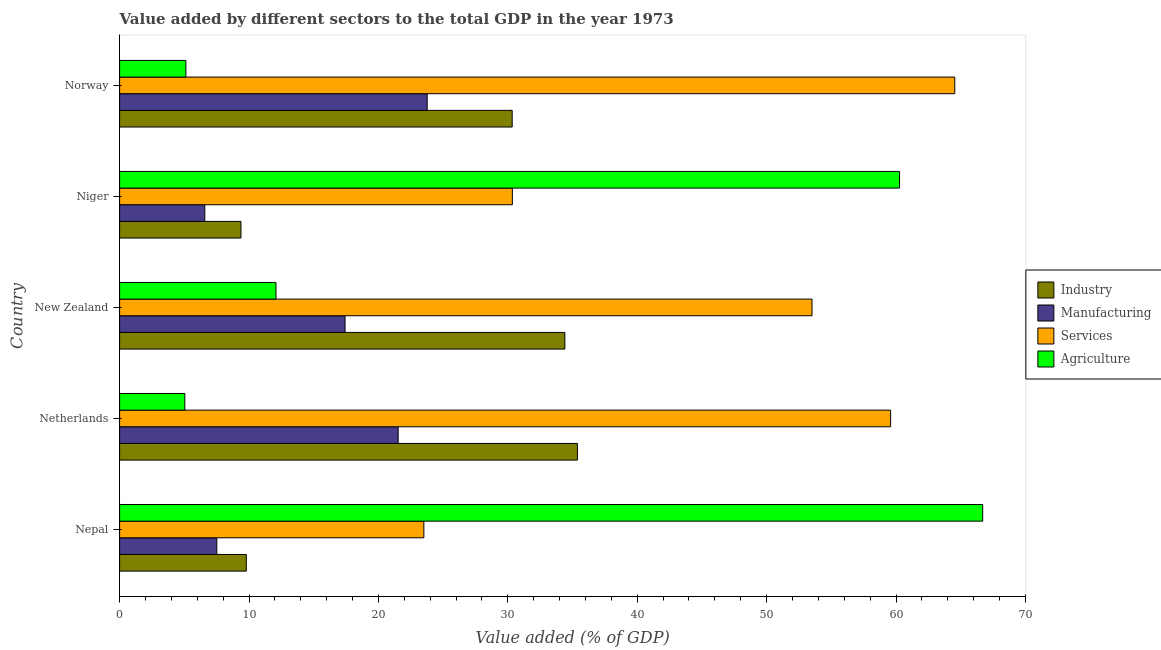How many groups of bars are there?
Give a very brief answer. 5. Are the number of bars per tick equal to the number of legend labels?
Provide a succinct answer. Yes. How many bars are there on the 3rd tick from the top?
Keep it short and to the point. 4. What is the label of the 1st group of bars from the top?
Keep it short and to the point. Norway. What is the value added by agricultural sector in Netherlands?
Provide a succinct answer. 5.04. Across all countries, what is the maximum value added by agricultural sector?
Give a very brief answer. 66.7. Across all countries, what is the minimum value added by manufacturing sector?
Offer a very short reply. 6.58. In which country was the value added by agricultural sector maximum?
Keep it short and to the point. Nepal. In which country was the value added by agricultural sector minimum?
Your answer should be very brief. Netherlands. What is the total value added by industrial sector in the graph?
Ensure brevity in your answer.  119.29. What is the difference between the value added by industrial sector in Niger and that in Norway?
Your answer should be compact. -20.96. What is the difference between the value added by services sector in Netherlands and the value added by agricultural sector in Nepal?
Offer a terse response. -7.12. What is the average value added by services sector per country?
Provide a succinct answer. 46.3. What is the difference between the value added by industrial sector and value added by agricultural sector in Netherlands?
Ensure brevity in your answer.  30.34. What is the ratio of the value added by agricultural sector in Nepal to that in Niger?
Make the answer very short. 1.11. Is the difference between the value added by agricultural sector in New Zealand and Niger greater than the difference between the value added by industrial sector in New Zealand and Niger?
Give a very brief answer. No. What is the difference between the highest and the second highest value added by services sector?
Provide a short and direct response. 4.96. What is the difference between the highest and the lowest value added by manufacturing sector?
Your answer should be very brief. 17.19. In how many countries, is the value added by agricultural sector greater than the average value added by agricultural sector taken over all countries?
Your response must be concise. 2. Is the sum of the value added by agricultural sector in New Zealand and Norway greater than the maximum value added by manufacturing sector across all countries?
Give a very brief answer. No. What does the 3rd bar from the top in New Zealand represents?
Your response must be concise. Manufacturing. What does the 2nd bar from the bottom in Netherlands represents?
Keep it short and to the point. Manufacturing. Are all the bars in the graph horizontal?
Your answer should be very brief. Yes. What is the difference between two consecutive major ticks on the X-axis?
Offer a very short reply. 10. Does the graph contain grids?
Ensure brevity in your answer.  No. How many legend labels are there?
Provide a succinct answer. 4. How are the legend labels stacked?
Your answer should be very brief. Vertical. What is the title of the graph?
Offer a terse response. Value added by different sectors to the total GDP in the year 1973. What is the label or title of the X-axis?
Keep it short and to the point. Value added (% of GDP). What is the Value added (% of GDP) of Industry in Nepal?
Keep it short and to the point. 9.79. What is the Value added (% of GDP) in Manufacturing in Nepal?
Provide a succinct answer. 7.51. What is the Value added (% of GDP) in Services in Nepal?
Provide a succinct answer. 23.51. What is the Value added (% of GDP) of Agriculture in Nepal?
Give a very brief answer. 66.7. What is the Value added (% of GDP) in Industry in Netherlands?
Offer a terse response. 35.38. What is the Value added (% of GDP) in Manufacturing in Netherlands?
Offer a terse response. 21.53. What is the Value added (% of GDP) in Services in Netherlands?
Make the answer very short. 59.58. What is the Value added (% of GDP) in Agriculture in Netherlands?
Offer a very short reply. 5.04. What is the Value added (% of GDP) of Industry in New Zealand?
Ensure brevity in your answer.  34.41. What is the Value added (% of GDP) of Manufacturing in New Zealand?
Offer a terse response. 17.42. What is the Value added (% of GDP) in Services in New Zealand?
Make the answer very short. 53.51. What is the Value added (% of GDP) in Agriculture in New Zealand?
Make the answer very short. 12.08. What is the Value added (% of GDP) of Industry in Niger?
Make the answer very short. 9.38. What is the Value added (% of GDP) in Manufacturing in Niger?
Your answer should be very brief. 6.58. What is the Value added (% of GDP) in Services in Niger?
Give a very brief answer. 30.35. What is the Value added (% of GDP) of Agriculture in Niger?
Your response must be concise. 60.27. What is the Value added (% of GDP) in Industry in Norway?
Offer a terse response. 30.34. What is the Value added (% of GDP) of Manufacturing in Norway?
Provide a succinct answer. 23.77. What is the Value added (% of GDP) of Services in Norway?
Your answer should be very brief. 64.54. What is the Value added (% of GDP) of Agriculture in Norway?
Offer a very short reply. 5.12. Across all countries, what is the maximum Value added (% of GDP) of Industry?
Offer a very short reply. 35.38. Across all countries, what is the maximum Value added (% of GDP) in Manufacturing?
Offer a very short reply. 23.77. Across all countries, what is the maximum Value added (% of GDP) in Services?
Provide a short and direct response. 64.54. Across all countries, what is the maximum Value added (% of GDP) in Agriculture?
Make the answer very short. 66.7. Across all countries, what is the minimum Value added (% of GDP) of Industry?
Provide a succinct answer. 9.38. Across all countries, what is the minimum Value added (% of GDP) of Manufacturing?
Provide a succinct answer. 6.58. Across all countries, what is the minimum Value added (% of GDP) in Services?
Provide a succinct answer. 23.51. Across all countries, what is the minimum Value added (% of GDP) in Agriculture?
Your response must be concise. 5.04. What is the total Value added (% of GDP) in Industry in the graph?
Offer a terse response. 119.29. What is the total Value added (% of GDP) of Manufacturing in the graph?
Offer a terse response. 76.81. What is the total Value added (% of GDP) of Services in the graph?
Your answer should be compact. 231.49. What is the total Value added (% of GDP) in Agriculture in the graph?
Offer a terse response. 149.22. What is the difference between the Value added (% of GDP) of Industry in Nepal and that in Netherlands?
Your answer should be very brief. -25.59. What is the difference between the Value added (% of GDP) in Manufacturing in Nepal and that in Netherlands?
Provide a succinct answer. -14.02. What is the difference between the Value added (% of GDP) of Services in Nepal and that in Netherlands?
Offer a very short reply. -36.07. What is the difference between the Value added (% of GDP) in Agriculture in Nepal and that in Netherlands?
Your response must be concise. 61.66. What is the difference between the Value added (% of GDP) in Industry in Nepal and that in New Zealand?
Give a very brief answer. -24.62. What is the difference between the Value added (% of GDP) of Manufacturing in Nepal and that in New Zealand?
Your response must be concise. -9.91. What is the difference between the Value added (% of GDP) of Services in Nepal and that in New Zealand?
Give a very brief answer. -29.99. What is the difference between the Value added (% of GDP) of Agriculture in Nepal and that in New Zealand?
Your answer should be compact. 54.61. What is the difference between the Value added (% of GDP) of Industry in Nepal and that in Niger?
Offer a very short reply. 0.41. What is the difference between the Value added (% of GDP) in Manufacturing in Nepal and that in Niger?
Your answer should be very brief. 0.93. What is the difference between the Value added (% of GDP) of Services in Nepal and that in Niger?
Offer a terse response. -6.84. What is the difference between the Value added (% of GDP) of Agriculture in Nepal and that in Niger?
Your answer should be compact. 6.43. What is the difference between the Value added (% of GDP) of Industry in Nepal and that in Norway?
Ensure brevity in your answer.  -20.55. What is the difference between the Value added (% of GDP) in Manufacturing in Nepal and that in Norway?
Keep it short and to the point. -16.26. What is the difference between the Value added (% of GDP) of Services in Nepal and that in Norway?
Offer a very short reply. -41.03. What is the difference between the Value added (% of GDP) of Agriculture in Nepal and that in Norway?
Offer a terse response. 61.57. What is the difference between the Value added (% of GDP) in Industry in Netherlands and that in New Zealand?
Give a very brief answer. 0.97. What is the difference between the Value added (% of GDP) of Manufacturing in Netherlands and that in New Zealand?
Offer a very short reply. 4.1. What is the difference between the Value added (% of GDP) in Services in Netherlands and that in New Zealand?
Offer a very short reply. 6.07. What is the difference between the Value added (% of GDP) of Agriculture in Netherlands and that in New Zealand?
Your answer should be very brief. -7.04. What is the difference between the Value added (% of GDP) of Industry in Netherlands and that in Niger?
Provide a succinct answer. 26. What is the difference between the Value added (% of GDP) in Manufacturing in Netherlands and that in Niger?
Your response must be concise. 14.94. What is the difference between the Value added (% of GDP) in Services in Netherlands and that in Niger?
Provide a succinct answer. 29.23. What is the difference between the Value added (% of GDP) in Agriculture in Netherlands and that in Niger?
Keep it short and to the point. -55.23. What is the difference between the Value added (% of GDP) of Industry in Netherlands and that in Norway?
Your response must be concise. 5.04. What is the difference between the Value added (% of GDP) of Manufacturing in Netherlands and that in Norway?
Offer a very short reply. -2.24. What is the difference between the Value added (% of GDP) in Services in Netherlands and that in Norway?
Your answer should be very brief. -4.96. What is the difference between the Value added (% of GDP) in Agriculture in Netherlands and that in Norway?
Your answer should be compact. -0.08. What is the difference between the Value added (% of GDP) in Industry in New Zealand and that in Niger?
Your response must be concise. 25.03. What is the difference between the Value added (% of GDP) in Manufacturing in New Zealand and that in Niger?
Ensure brevity in your answer.  10.84. What is the difference between the Value added (% of GDP) of Services in New Zealand and that in Niger?
Make the answer very short. 23.16. What is the difference between the Value added (% of GDP) of Agriculture in New Zealand and that in Niger?
Provide a succinct answer. -48.19. What is the difference between the Value added (% of GDP) of Industry in New Zealand and that in Norway?
Offer a terse response. 4.07. What is the difference between the Value added (% of GDP) in Manufacturing in New Zealand and that in Norway?
Offer a very short reply. -6.35. What is the difference between the Value added (% of GDP) of Services in New Zealand and that in Norway?
Your answer should be compact. -11.03. What is the difference between the Value added (% of GDP) in Agriculture in New Zealand and that in Norway?
Your answer should be very brief. 6.96. What is the difference between the Value added (% of GDP) in Industry in Niger and that in Norway?
Your response must be concise. -20.96. What is the difference between the Value added (% of GDP) of Manufacturing in Niger and that in Norway?
Offer a very short reply. -17.19. What is the difference between the Value added (% of GDP) in Services in Niger and that in Norway?
Make the answer very short. -34.19. What is the difference between the Value added (% of GDP) of Agriculture in Niger and that in Norway?
Make the answer very short. 55.15. What is the difference between the Value added (% of GDP) in Industry in Nepal and the Value added (% of GDP) in Manufacturing in Netherlands?
Provide a short and direct response. -11.74. What is the difference between the Value added (% of GDP) in Industry in Nepal and the Value added (% of GDP) in Services in Netherlands?
Offer a terse response. -49.79. What is the difference between the Value added (% of GDP) in Industry in Nepal and the Value added (% of GDP) in Agriculture in Netherlands?
Give a very brief answer. 4.75. What is the difference between the Value added (% of GDP) of Manufacturing in Nepal and the Value added (% of GDP) of Services in Netherlands?
Give a very brief answer. -52.07. What is the difference between the Value added (% of GDP) in Manufacturing in Nepal and the Value added (% of GDP) in Agriculture in Netherlands?
Your response must be concise. 2.47. What is the difference between the Value added (% of GDP) in Services in Nepal and the Value added (% of GDP) in Agriculture in Netherlands?
Keep it short and to the point. 18.47. What is the difference between the Value added (% of GDP) of Industry in Nepal and the Value added (% of GDP) of Manufacturing in New Zealand?
Provide a short and direct response. -7.63. What is the difference between the Value added (% of GDP) in Industry in Nepal and the Value added (% of GDP) in Services in New Zealand?
Provide a succinct answer. -43.72. What is the difference between the Value added (% of GDP) in Industry in Nepal and the Value added (% of GDP) in Agriculture in New Zealand?
Your answer should be compact. -2.29. What is the difference between the Value added (% of GDP) of Manufacturing in Nepal and the Value added (% of GDP) of Services in New Zealand?
Make the answer very short. -46. What is the difference between the Value added (% of GDP) in Manufacturing in Nepal and the Value added (% of GDP) in Agriculture in New Zealand?
Offer a very short reply. -4.57. What is the difference between the Value added (% of GDP) of Services in Nepal and the Value added (% of GDP) of Agriculture in New Zealand?
Provide a short and direct response. 11.43. What is the difference between the Value added (% of GDP) in Industry in Nepal and the Value added (% of GDP) in Manufacturing in Niger?
Ensure brevity in your answer.  3.21. What is the difference between the Value added (% of GDP) of Industry in Nepal and the Value added (% of GDP) of Services in Niger?
Give a very brief answer. -20.56. What is the difference between the Value added (% of GDP) in Industry in Nepal and the Value added (% of GDP) in Agriculture in Niger?
Your response must be concise. -50.48. What is the difference between the Value added (% of GDP) in Manufacturing in Nepal and the Value added (% of GDP) in Services in Niger?
Give a very brief answer. -22.84. What is the difference between the Value added (% of GDP) of Manufacturing in Nepal and the Value added (% of GDP) of Agriculture in Niger?
Your response must be concise. -52.76. What is the difference between the Value added (% of GDP) in Services in Nepal and the Value added (% of GDP) in Agriculture in Niger?
Ensure brevity in your answer.  -36.76. What is the difference between the Value added (% of GDP) of Industry in Nepal and the Value added (% of GDP) of Manufacturing in Norway?
Offer a very short reply. -13.98. What is the difference between the Value added (% of GDP) of Industry in Nepal and the Value added (% of GDP) of Services in Norway?
Keep it short and to the point. -54.75. What is the difference between the Value added (% of GDP) in Industry in Nepal and the Value added (% of GDP) in Agriculture in Norway?
Provide a succinct answer. 4.67. What is the difference between the Value added (% of GDP) of Manufacturing in Nepal and the Value added (% of GDP) of Services in Norway?
Offer a very short reply. -57.03. What is the difference between the Value added (% of GDP) in Manufacturing in Nepal and the Value added (% of GDP) in Agriculture in Norway?
Your answer should be very brief. 2.39. What is the difference between the Value added (% of GDP) in Services in Nepal and the Value added (% of GDP) in Agriculture in Norway?
Provide a short and direct response. 18.39. What is the difference between the Value added (% of GDP) of Industry in Netherlands and the Value added (% of GDP) of Manufacturing in New Zealand?
Make the answer very short. 17.96. What is the difference between the Value added (% of GDP) of Industry in Netherlands and the Value added (% of GDP) of Services in New Zealand?
Your response must be concise. -18.13. What is the difference between the Value added (% of GDP) of Industry in Netherlands and the Value added (% of GDP) of Agriculture in New Zealand?
Your answer should be compact. 23.3. What is the difference between the Value added (% of GDP) of Manufacturing in Netherlands and the Value added (% of GDP) of Services in New Zealand?
Ensure brevity in your answer.  -31.98. What is the difference between the Value added (% of GDP) of Manufacturing in Netherlands and the Value added (% of GDP) of Agriculture in New Zealand?
Provide a succinct answer. 9.44. What is the difference between the Value added (% of GDP) of Services in Netherlands and the Value added (% of GDP) of Agriculture in New Zealand?
Your response must be concise. 47.5. What is the difference between the Value added (% of GDP) of Industry in Netherlands and the Value added (% of GDP) of Manufacturing in Niger?
Provide a short and direct response. 28.8. What is the difference between the Value added (% of GDP) of Industry in Netherlands and the Value added (% of GDP) of Services in Niger?
Provide a short and direct response. 5.03. What is the difference between the Value added (% of GDP) in Industry in Netherlands and the Value added (% of GDP) in Agriculture in Niger?
Make the answer very short. -24.89. What is the difference between the Value added (% of GDP) of Manufacturing in Netherlands and the Value added (% of GDP) of Services in Niger?
Ensure brevity in your answer.  -8.82. What is the difference between the Value added (% of GDP) in Manufacturing in Netherlands and the Value added (% of GDP) in Agriculture in Niger?
Offer a terse response. -38.74. What is the difference between the Value added (% of GDP) of Services in Netherlands and the Value added (% of GDP) of Agriculture in Niger?
Keep it short and to the point. -0.69. What is the difference between the Value added (% of GDP) of Industry in Netherlands and the Value added (% of GDP) of Manufacturing in Norway?
Offer a terse response. 11.61. What is the difference between the Value added (% of GDP) in Industry in Netherlands and the Value added (% of GDP) in Services in Norway?
Your answer should be very brief. -29.16. What is the difference between the Value added (% of GDP) in Industry in Netherlands and the Value added (% of GDP) in Agriculture in Norway?
Make the answer very short. 30.26. What is the difference between the Value added (% of GDP) of Manufacturing in Netherlands and the Value added (% of GDP) of Services in Norway?
Provide a short and direct response. -43.01. What is the difference between the Value added (% of GDP) of Manufacturing in Netherlands and the Value added (% of GDP) of Agriculture in Norway?
Make the answer very short. 16.4. What is the difference between the Value added (% of GDP) in Services in Netherlands and the Value added (% of GDP) in Agriculture in Norway?
Your answer should be very brief. 54.46. What is the difference between the Value added (% of GDP) in Industry in New Zealand and the Value added (% of GDP) in Manufacturing in Niger?
Offer a very short reply. 27.83. What is the difference between the Value added (% of GDP) in Industry in New Zealand and the Value added (% of GDP) in Services in Niger?
Offer a very short reply. 4.06. What is the difference between the Value added (% of GDP) in Industry in New Zealand and the Value added (% of GDP) in Agriculture in Niger?
Your response must be concise. -25.86. What is the difference between the Value added (% of GDP) of Manufacturing in New Zealand and the Value added (% of GDP) of Services in Niger?
Your answer should be very brief. -12.93. What is the difference between the Value added (% of GDP) of Manufacturing in New Zealand and the Value added (% of GDP) of Agriculture in Niger?
Make the answer very short. -42.85. What is the difference between the Value added (% of GDP) of Services in New Zealand and the Value added (% of GDP) of Agriculture in Niger?
Keep it short and to the point. -6.76. What is the difference between the Value added (% of GDP) of Industry in New Zealand and the Value added (% of GDP) of Manufacturing in Norway?
Your answer should be very brief. 10.64. What is the difference between the Value added (% of GDP) of Industry in New Zealand and the Value added (% of GDP) of Services in Norway?
Offer a very short reply. -30.13. What is the difference between the Value added (% of GDP) in Industry in New Zealand and the Value added (% of GDP) in Agriculture in Norway?
Your answer should be very brief. 29.29. What is the difference between the Value added (% of GDP) in Manufacturing in New Zealand and the Value added (% of GDP) in Services in Norway?
Ensure brevity in your answer.  -47.12. What is the difference between the Value added (% of GDP) in Manufacturing in New Zealand and the Value added (% of GDP) in Agriculture in Norway?
Ensure brevity in your answer.  12.3. What is the difference between the Value added (% of GDP) in Services in New Zealand and the Value added (% of GDP) in Agriculture in Norway?
Offer a terse response. 48.38. What is the difference between the Value added (% of GDP) of Industry in Niger and the Value added (% of GDP) of Manufacturing in Norway?
Offer a terse response. -14.39. What is the difference between the Value added (% of GDP) in Industry in Niger and the Value added (% of GDP) in Services in Norway?
Your response must be concise. -55.16. What is the difference between the Value added (% of GDP) of Industry in Niger and the Value added (% of GDP) of Agriculture in Norway?
Your response must be concise. 4.25. What is the difference between the Value added (% of GDP) in Manufacturing in Niger and the Value added (% of GDP) in Services in Norway?
Offer a very short reply. -57.96. What is the difference between the Value added (% of GDP) in Manufacturing in Niger and the Value added (% of GDP) in Agriculture in Norway?
Give a very brief answer. 1.46. What is the difference between the Value added (% of GDP) of Services in Niger and the Value added (% of GDP) of Agriculture in Norway?
Give a very brief answer. 25.23. What is the average Value added (% of GDP) of Industry per country?
Offer a terse response. 23.86. What is the average Value added (% of GDP) of Manufacturing per country?
Offer a terse response. 15.36. What is the average Value added (% of GDP) in Services per country?
Offer a very short reply. 46.3. What is the average Value added (% of GDP) of Agriculture per country?
Make the answer very short. 29.84. What is the difference between the Value added (% of GDP) in Industry and Value added (% of GDP) in Manufacturing in Nepal?
Ensure brevity in your answer.  2.28. What is the difference between the Value added (% of GDP) of Industry and Value added (% of GDP) of Services in Nepal?
Your answer should be very brief. -13.72. What is the difference between the Value added (% of GDP) of Industry and Value added (% of GDP) of Agriculture in Nepal?
Provide a succinct answer. -56.91. What is the difference between the Value added (% of GDP) in Manufacturing and Value added (% of GDP) in Services in Nepal?
Your response must be concise. -16. What is the difference between the Value added (% of GDP) in Manufacturing and Value added (% of GDP) in Agriculture in Nepal?
Your answer should be compact. -59.19. What is the difference between the Value added (% of GDP) of Services and Value added (% of GDP) of Agriculture in Nepal?
Keep it short and to the point. -43.18. What is the difference between the Value added (% of GDP) in Industry and Value added (% of GDP) in Manufacturing in Netherlands?
Your answer should be compact. 13.85. What is the difference between the Value added (% of GDP) in Industry and Value added (% of GDP) in Services in Netherlands?
Ensure brevity in your answer.  -24.2. What is the difference between the Value added (% of GDP) in Industry and Value added (% of GDP) in Agriculture in Netherlands?
Ensure brevity in your answer.  30.34. What is the difference between the Value added (% of GDP) in Manufacturing and Value added (% of GDP) in Services in Netherlands?
Offer a terse response. -38.05. What is the difference between the Value added (% of GDP) in Manufacturing and Value added (% of GDP) in Agriculture in Netherlands?
Provide a succinct answer. 16.49. What is the difference between the Value added (% of GDP) of Services and Value added (% of GDP) of Agriculture in Netherlands?
Your response must be concise. 54.54. What is the difference between the Value added (% of GDP) of Industry and Value added (% of GDP) of Manufacturing in New Zealand?
Keep it short and to the point. 16.99. What is the difference between the Value added (% of GDP) in Industry and Value added (% of GDP) in Services in New Zealand?
Your answer should be very brief. -19.1. What is the difference between the Value added (% of GDP) in Industry and Value added (% of GDP) in Agriculture in New Zealand?
Ensure brevity in your answer.  22.32. What is the difference between the Value added (% of GDP) of Manufacturing and Value added (% of GDP) of Services in New Zealand?
Your answer should be very brief. -36.09. What is the difference between the Value added (% of GDP) of Manufacturing and Value added (% of GDP) of Agriculture in New Zealand?
Your response must be concise. 5.34. What is the difference between the Value added (% of GDP) in Services and Value added (% of GDP) in Agriculture in New Zealand?
Ensure brevity in your answer.  41.42. What is the difference between the Value added (% of GDP) of Industry and Value added (% of GDP) of Manufacturing in Niger?
Offer a very short reply. 2.8. What is the difference between the Value added (% of GDP) in Industry and Value added (% of GDP) in Services in Niger?
Your answer should be compact. -20.97. What is the difference between the Value added (% of GDP) in Industry and Value added (% of GDP) in Agriculture in Niger?
Your answer should be compact. -50.89. What is the difference between the Value added (% of GDP) in Manufacturing and Value added (% of GDP) in Services in Niger?
Make the answer very short. -23.77. What is the difference between the Value added (% of GDP) of Manufacturing and Value added (% of GDP) of Agriculture in Niger?
Make the answer very short. -53.69. What is the difference between the Value added (% of GDP) in Services and Value added (% of GDP) in Agriculture in Niger?
Your answer should be very brief. -29.92. What is the difference between the Value added (% of GDP) in Industry and Value added (% of GDP) in Manufacturing in Norway?
Offer a very short reply. 6.57. What is the difference between the Value added (% of GDP) in Industry and Value added (% of GDP) in Services in Norway?
Give a very brief answer. -34.2. What is the difference between the Value added (% of GDP) in Industry and Value added (% of GDP) in Agriculture in Norway?
Give a very brief answer. 25.21. What is the difference between the Value added (% of GDP) in Manufacturing and Value added (% of GDP) in Services in Norway?
Your response must be concise. -40.77. What is the difference between the Value added (% of GDP) of Manufacturing and Value added (% of GDP) of Agriculture in Norway?
Give a very brief answer. 18.65. What is the difference between the Value added (% of GDP) in Services and Value added (% of GDP) in Agriculture in Norway?
Ensure brevity in your answer.  59.42. What is the ratio of the Value added (% of GDP) in Industry in Nepal to that in Netherlands?
Provide a short and direct response. 0.28. What is the ratio of the Value added (% of GDP) of Manufacturing in Nepal to that in Netherlands?
Your answer should be very brief. 0.35. What is the ratio of the Value added (% of GDP) in Services in Nepal to that in Netherlands?
Offer a terse response. 0.39. What is the ratio of the Value added (% of GDP) in Agriculture in Nepal to that in Netherlands?
Offer a terse response. 13.23. What is the ratio of the Value added (% of GDP) in Industry in Nepal to that in New Zealand?
Ensure brevity in your answer.  0.28. What is the ratio of the Value added (% of GDP) in Manufacturing in Nepal to that in New Zealand?
Your answer should be very brief. 0.43. What is the ratio of the Value added (% of GDP) of Services in Nepal to that in New Zealand?
Make the answer very short. 0.44. What is the ratio of the Value added (% of GDP) in Agriculture in Nepal to that in New Zealand?
Your answer should be compact. 5.52. What is the ratio of the Value added (% of GDP) of Industry in Nepal to that in Niger?
Make the answer very short. 1.04. What is the ratio of the Value added (% of GDP) in Manufacturing in Nepal to that in Niger?
Offer a terse response. 1.14. What is the ratio of the Value added (% of GDP) of Services in Nepal to that in Niger?
Provide a succinct answer. 0.77. What is the ratio of the Value added (% of GDP) in Agriculture in Nepal to that in Niger?
Keep it short and to the point. 1.11. What is the ratio of the Value added (% of GDP) of Industry in Nepal to that in Norway?
Provide a short and direct response. 0.32. What is the ratio of the Value added (% of GDP) in Manufacturing in Nepal to that in Norway?
Offer a terse response. 0.32. What is the ratio of the Value added (% of GDP) of Services in Nepal to that in Norway?
Your answer should be compact. 0.36. What is the ratio of the Value added (% of GDP) of Agriculture in Nepal to that in Norway?
Your answer should be very brief. 13.02. What is the ratio of the Value added (% of GDP) in Industry in Netherlands to that in New Zealand?
Your answer should be compact. 1.03. What is the ratio of the Value added (% of GDP) in Manufacturing in Netherlands to that in New Zealand?
Make the answer very short. 1.24. What is the ratio of the Value added (% of GDP) of Services in Netherlands to that in New Zealand?
Make the answer very short. 1.11. What is the ratio of the Value added (% of GDP) in Agriculture in Netherlands to that in New Zealand?
Your answer should be very brief. 0.42. What is the ratio of the Value added (% of GDP) of Industry in Netherlands to that in Niger?
Offer a very short reply. 3.77. What is the ratio of the Value added (% of GDP) in Manufacturing in Netherlands to that in Niger?
Your answer should be compact. 3.27. What is the ratio of the Value added (% of GDP) in Services in Netherlands to that in Niger?
Your answer should be very brief. 1.96. What is the ratio of the Value added (% of GDP) in Agriculture in Netherlands to that in Niger?
Ensure brevity in your answer.  0.08. What is the ratio of the Value added (% of GDP) in Industry in Netherlands to that in Norway?
Make the answer very short. 1.17. What is the ratio of the Value added (% of GDP) of Manufacturing in Netherlands to that in Norway?
Keep it short and to the point. 0.91. What is the ratio of the Value added (% of GDP) of Services in Netherlands to that in Norway?
Keep it short and to the point. 0.92. What is the ratio of the Value added (% of GDP) in Agriculture in Netherlands to that in Norway?
Keep it short and to the point. 0.98. What is the ratio of the Value added (% of GDP) in Industry in New Zealand to that in Niger?
Offer a very short reply. 3.67. What is the ratio of the Value added (% of GDP) in Manufacturing in New Zealand to that in Niger?
Provide a short and direct response. 2.65. What is the ratio of the Value added (% of GDP) in Services in New Zealand to that in Niger?
Your answer should be compact. 1.76. What is the ratio of the Value added (% of GDP) in Agriculture in New Zealand to that in Niger?
Keep it short and to the point. 0.2. What is the ratio of the Value added (% of GDP) of Industry in New Zealand to that in Norway?
Your response must be concise. 1.13. What is the ratio of the Value added (% of GDP) in Manufacturing in New Zealand to that in Norway?
Make the answer very short. 0.73. What is the ratio of the Value added (% of GDP) in Services in New Zealand to that in Norway?
Your response must be concise. 0.83. What is the ratio of the Value added (% of GDP) of Agriculture in New Zealand to that in Norway?
Your answer should be very brief. 2.36. What is the ratio of the Value added (% of GDP) of Industry in Niger to that in Norway?
Make the answer very short. 0.31. What is the ratio of the Value added (% of GDP) of Manufacturing in Niger to that in Norway?
Your answer should be compact. 0.28. What is the ratio of the Value added (% of GDP) in Services in Niger to that in Norway?
Provide a short and direct response. 0.47. What is the ratio of the Value added (% of GDP) of Agriculture in Niger to that in Norway?
Your answer should be compact. 11.76. What is the difference between the highest and the second highest Value added (% of GDP) in Industry?
Provide a short and direct response. 0.97. What is the difference between the highest and the second highest Value added (% of GDP) in Manufacturing?
Your answer should be compact. 2.24. What is the difference between the highest and the second highest Value added (% of GDP) in Services?
Make the answer very short. 4.96. What is the difference between the highest and the second highest Value added (% of GDP) in Agriculture?
Make the answer very short. 6.43. What is the difference between the highest and the lowest Value added (% of GDP) in Industry?
Provide a short and direct response. 26. What is the difference between the highest and the lowest Value added (% of GDP) of Manufacturing?
Provide a succinct answer. 17.19. What is the difference between the highest and the lowest Value added (% of GDP) in Services?
Keep it short and to the point. 41.03. What is the difference between the highest and the lowest Value added (% of GDP) in Agriculture?
Give a very brief answer. 61.66. 